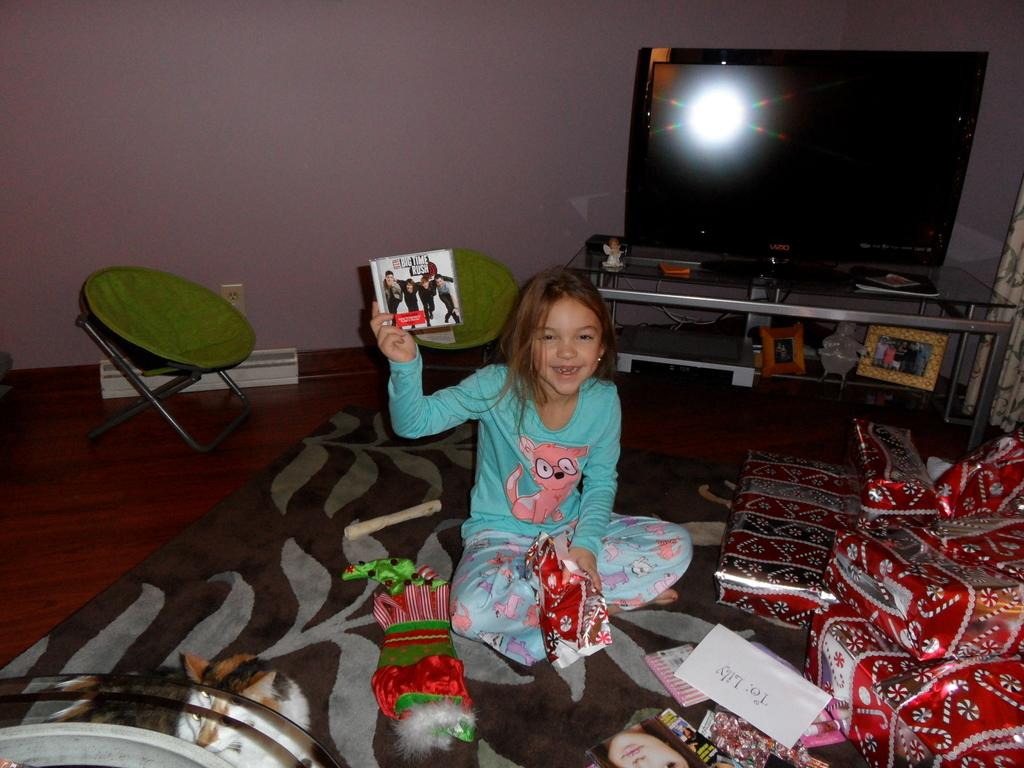What is the child doing in the image? The child is sitting and smiling in the image. What is the child holding in her hand? The child is holding an object in her hand. What is the child sitting on in the image? There is a chair in the image, which the child is likely sitting on. What is present in the background of the image? There is a TV and gifts in the image. Are there any animals present in the image? Yes, there is a cat in the image. What type of arch can be seen in the image? There is no arch present in the image. What effect does the cave have on the child's mood in the image? There is no cave present in the image, so it cannot have any effect on the child's mood. 